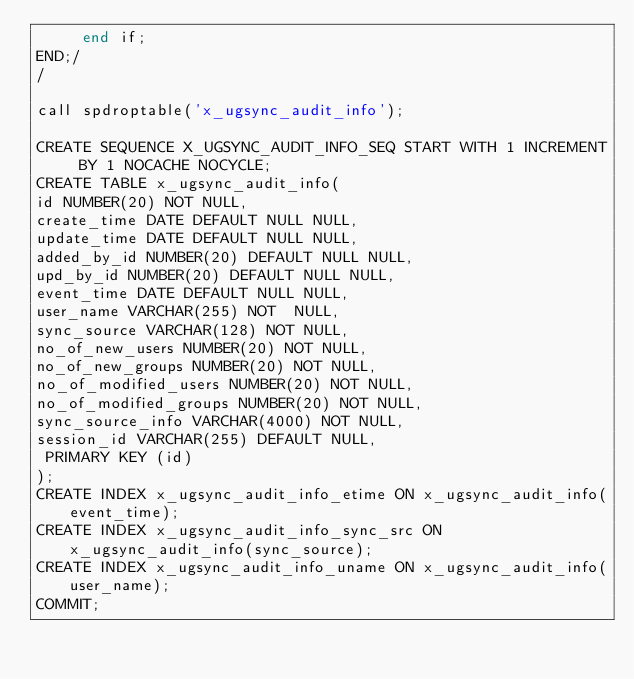Convert code to text. <code><loc_0><loc_0><loc_500><loc_500><_SQL_>     end if;
END;/
/

call spdroptable('x_ugsync_audit_info');

CREATE SEQUENCE X_UGSYNC_AUDIT_INFO_SEQ START WITH 1 INCREMENT BY 1 NOCACHE NOCYCLE;
CREATE TABLE x_ugsync_audit_info(
id NUMBER(20) NOT NULL,
create_time DATE DEFAULT NULL NULL,
update_time DATE DEFAULT NULL NULL,
added_by_id NUMBER(20) DEFAULT NULL NULL,
upd_by_id NUMBER(20) DEFAULT NULL NULL,
event_time DATE DEFAULT NULL NULL,
user_name VARCHAR(255) NOT  NULL,
sync_source VARCHAR(128) NOT NULL,
no_of_new_users NUMBER(20) NOT NULL,
no_of_new_groups NUMBER(20) NOT NULL,
no_of_modified_users NUMBER(20) NOT NULL,
no_of_modified_groups NUMBER(20) NOT NULL,
sync_source_info VARCHAR(4000) NOT NULL,
session_id VARCHAR(255) DEFAULT NULL,
 PRIMARY KEY (id)
);
CREATE INDEX x_ugsync_audit_info_etime ON x_ugsync_audit_info(event_time);
CREATE INDEX x_ugsync_audit_info_sync_src ON x_ugsync_audit_info(sync_source);
CREATE INDEX x_ugsync_audit_info_uname ON x_ugsync_audit_info(user_name);
COMMIT;</code> 